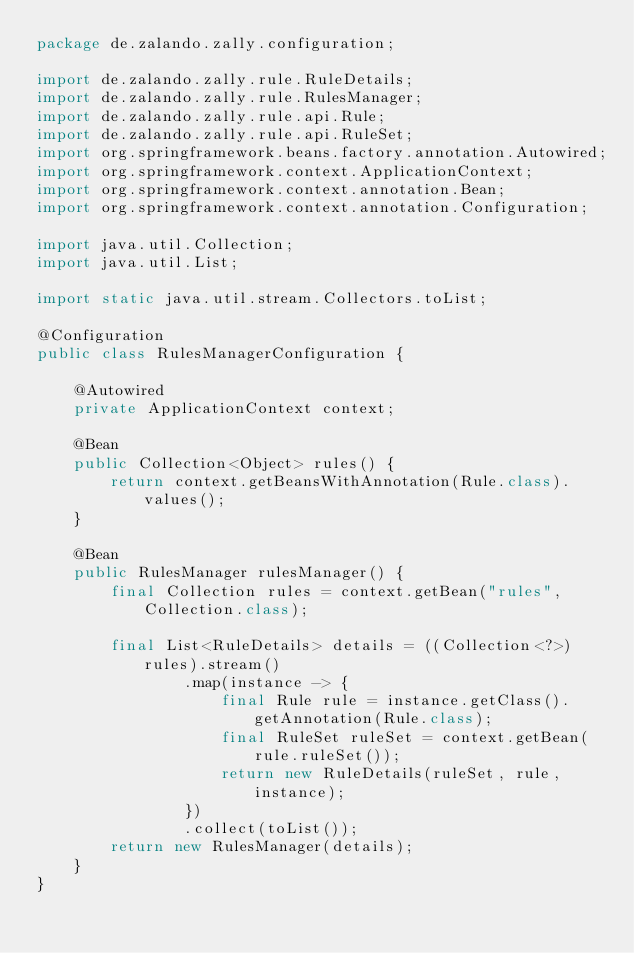Convert code to text. <code><loc_0><loc_0><loc_500><loc_500><_Java_>package de.zalando.zally.configuration;

import de.zalando.zally.rule.RuleDetails;
import de.zalando.zally.rule.RulesManager;
import de.zalando.zally.rule.api.Rule;
import de.zalando.zally.rule.api.RuleSet;
import org.springframework.beans.factory.annotation.Autowired;
import org.springframework.context.ApplicationContext;
import org.springframework.context.annotation.Bean;
import org.springframework.context.annotation.Configuration;

import java.util.Collection;
import java.util.List;

import static java.util.stream.Collectors.toList;

@Configuration
public class RulesManagerConfiguration {

    @Autowired
    private ApplicationContext context;

    @Bean
    public Collection<Object> rules() {
        return context.getBeansWithAnnotation(Rule.class).values();
    }

    @Bean
    public RulesManager rulesManager() {
        final Collection rules = context.getBean("rules", Collection.class);

        final List<RuleDetails> details = ((Collection<?>) rules).stream()
                .map(instance -> {
                    final Rule rule = instance.getClass().getAnnotation(Rule.class);
                    final RuleSet ruleSet = context.getBean(rule.ruleSet());
                    return new RuleDetails(ruleSet, rule, instance);
                })
                .collect(toList());
        return new RulesManager(details);
    }
}
</code> 